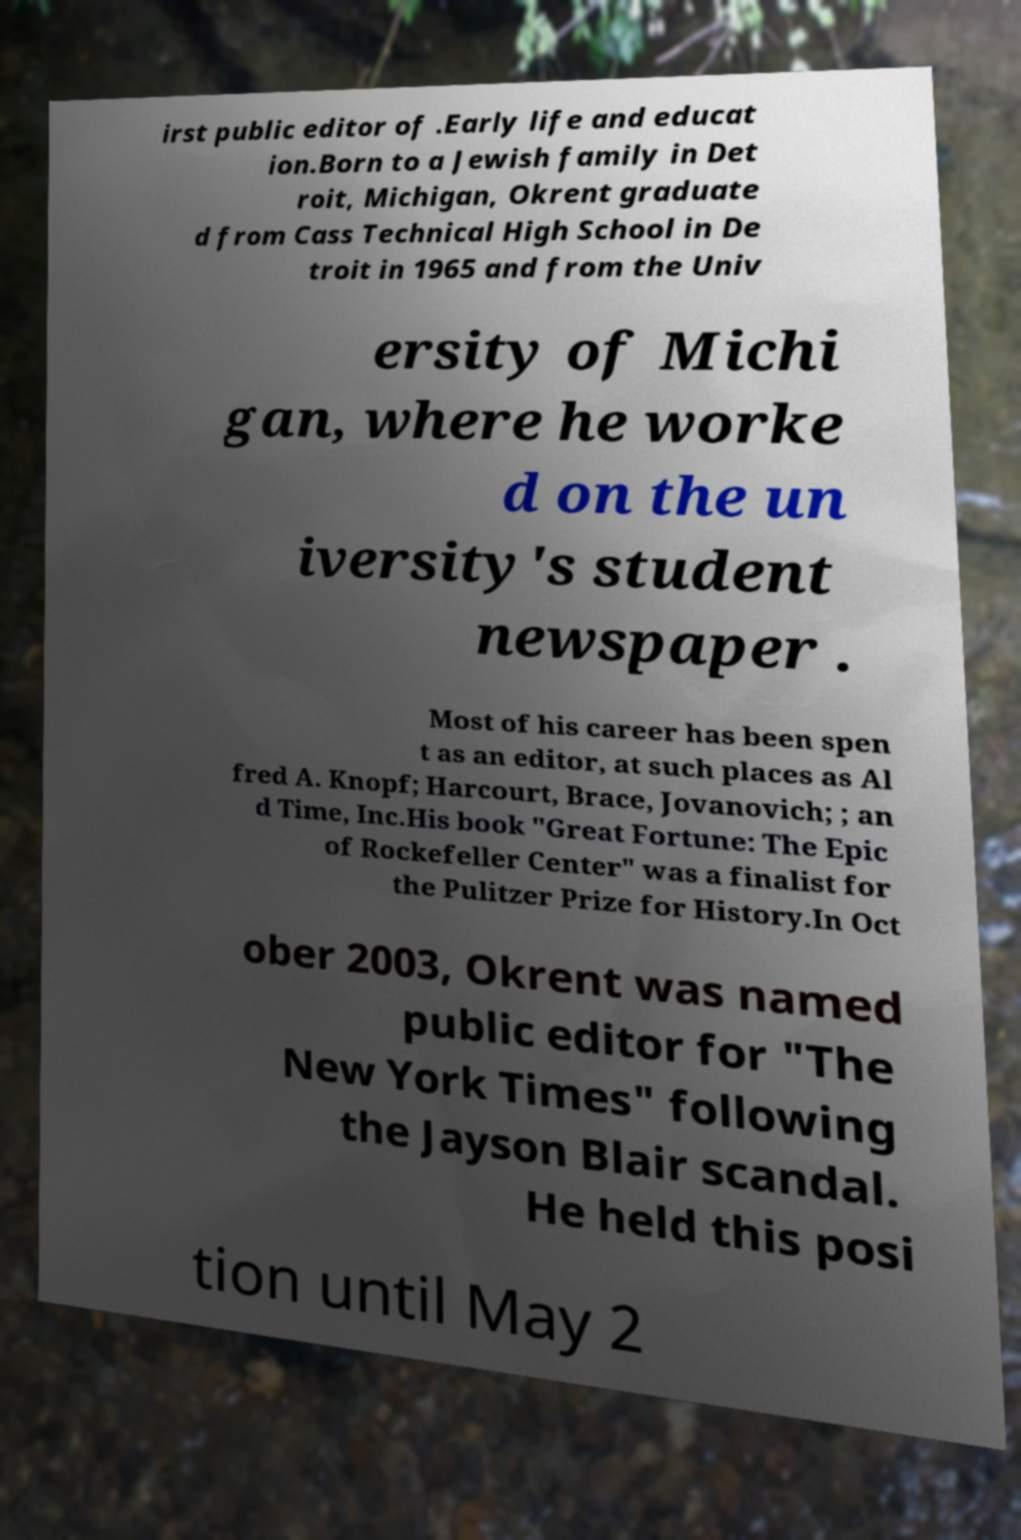I need the written content from this picture converted into text. Can you do that? irst public editor of .Early life and educat ion.Born to a Jewish family in Det roit, Michigan, Okrent graduate d from Cass Technical High School in De troit in 1965 and from the Univ ersity of Michi gan, where he worke d on the un iversity's student newspaper . Most of his career has been spen t as an editor, at such places as Al fred A. Knopf; Harcourt, Brace, Jovanovich; ; an d Time, Inc.His book "Great Fortune: The Epic of Rockefeller Center" was a finalist for the Pulitzer Prize for History.In Oct ober 2003, Okrent was named public editor for "The New York Times" following the Jayson Blair scandal. He held this posi tion until May 2 